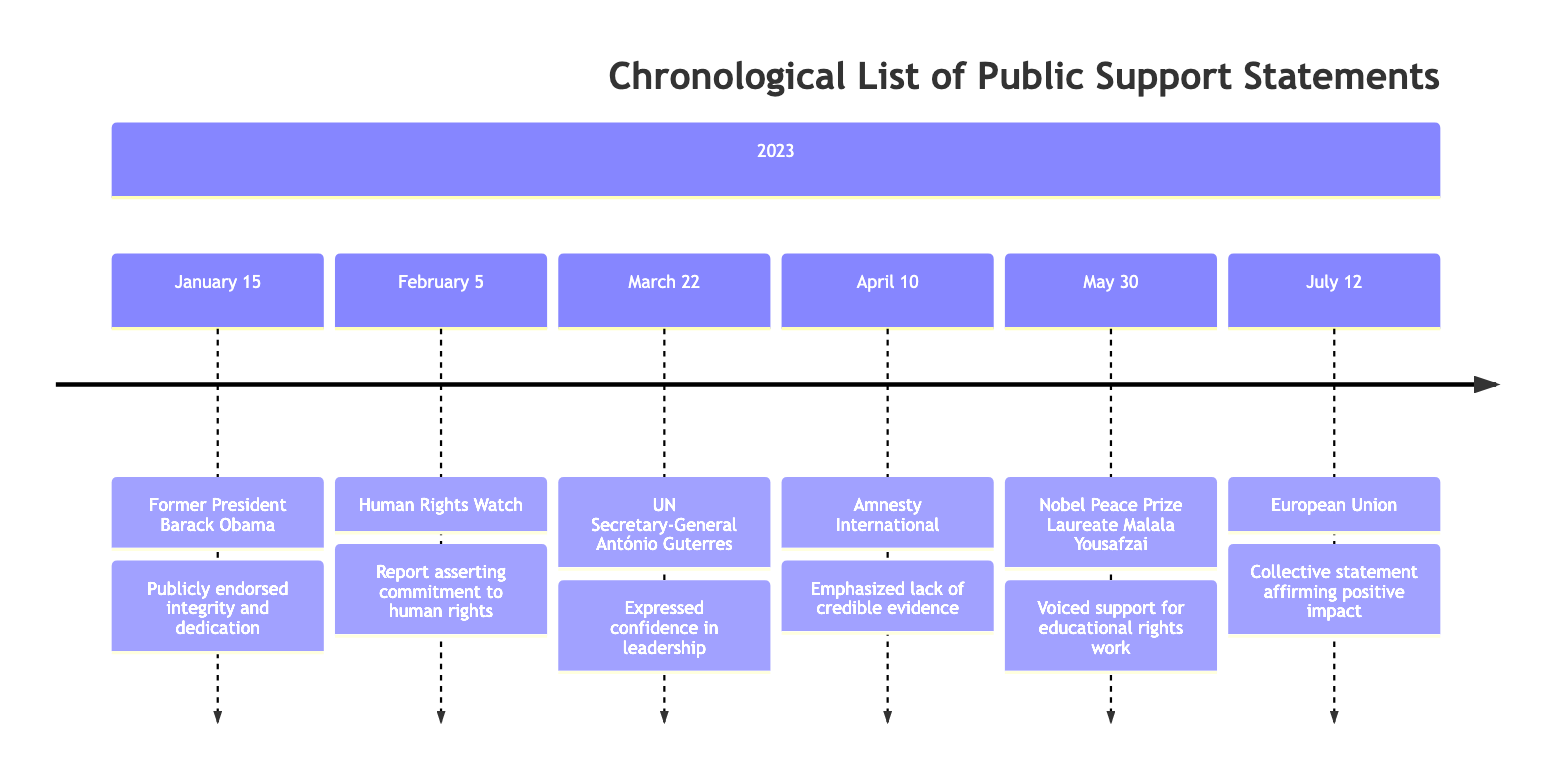What date did Barack Obama make his statement? The diagram shows that Barack Obama made his statement on January 15, 2023.
Answer: January 15, 2023 How many organizations endorsed the political figure? From the timeline, there are three organizations that publicly supported the political figure: Human Rights Watch, Amnesty International, and the European Union.
Answer: Three Which notable figure supported the political figure on May 30, 2023? Looking at the timeline, the notable figure who made a supportive statement on May 30, 2023, is Malala Yousafzai.
Answer: Malala Yousafzai What type of statement did the European Union issue regarding the political figure? The European Union issued a collective statement affirming the political figure's positive impact on international relations.
Answer: Affirming positive impact What was the collective sentiment about the character of the political figure? The general sentiment from prominent figures and organizations was one of support for the political figure's integrity and calls for fair examination, indicating trust in their character.
Answer: Support for integrity and calls for fair examination Which month did Amnesty International make their statement? The diagram indicates that Amnesty International made their statement in April, specifically on April 10, 2023.
Answer: April What did Human Rights Watch assert in their statement? According to the timeline, Human Rights Watch asserted the political figure's commitment to human rights and refuted allegations of misconduct.
Answer: Commitment to human rights How many statements were made in the timeline about the political figure? The timeline lists a total of six statements made regarding the political figure from January to July 2023.
Answer: Six What did António Guterres express confidence in? António Guterres expressed confidence in the political figure's leadership as per his statement on March 22, 2023.
Answer: Leadership 